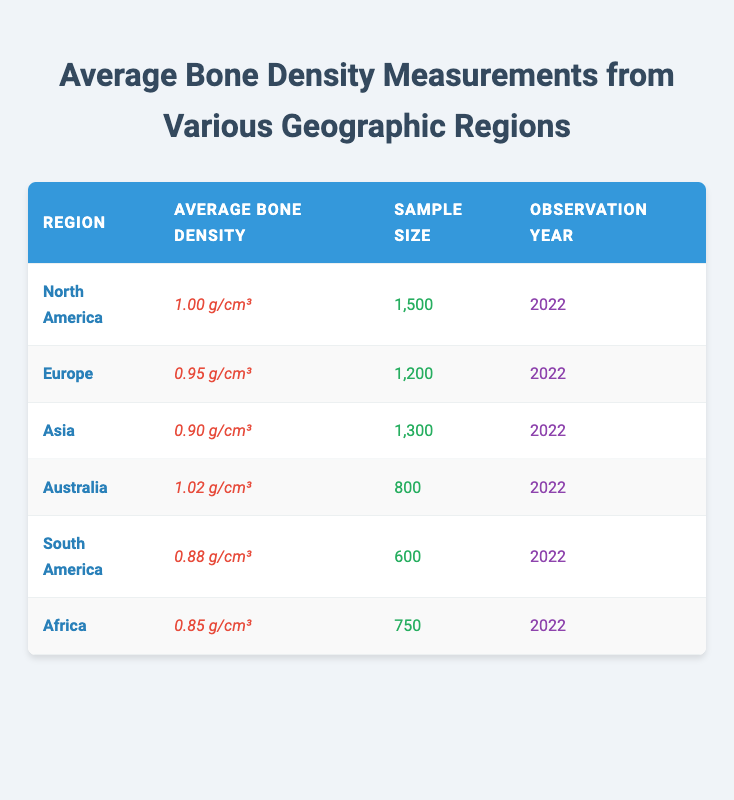What is the average bone density in North America? The table indicates that North America's average bone density is listed as 1.00 g/cm³.
Answer: 1.00 g/cm³ Which region has the highest average bone density? By looking at the average bone densities in the table, Australia has the highest value at 1.02 g/cm³.
Answer: Australia What is the sample size for Europe? The sample size for Europe, as stated in the table, is 1,200.
Answer: 1,200 Calculate the difference in average bone density between North America and Asia. North America has an average of 1.00 g/cm³ and Asia has 0.90 g/cm³. The difference is 1.00 - 0.90 = 0.10 g/cm³.
Answer: 0.10 g/cm³ Is the average bone density in South America greater than that in Africa? South America has an average bone density of 0.88 g/cm³ while Africa has 0.85 g/cm³. 0.88 is greater than 0.85, so the statement is true.
Answer: Yes What is the average bone density of the regions listed in the table? To find the average: (1.00 + 0.95 + 0.90 + 1.02 + 0.88 + 0.85) / 6 = 0.925 g/cm³.
Answer: 0.925 g/cm³ How many more participants were sampled in North America compared to South America? North America has a sample size of 1,500, and South America has 600. The difference is 1,500 - 600 = 900.
Answer: 900 Which region has the lowest average bone density? The table shows that Africa has the lowest average bone density at 0.85 g/cm³.
Answer: Africa If you sum the sample sizes of Australia and South America, what is the total? Australia's sample size is 800 and South America's is 600, so the sum is 800 + 600 = 1,400.
Answer: 1,400 Is the average bone density for Europe and Asia combined greater than that for Africa alone? Europe has 0.95 g/cm³ and Asia has 0.90 g/cm³, combined they total 0.95 + 0.90 = 1.85 g/cm³, which is greater than Africa's 0.85 g/cm³.
Answer: Yes 